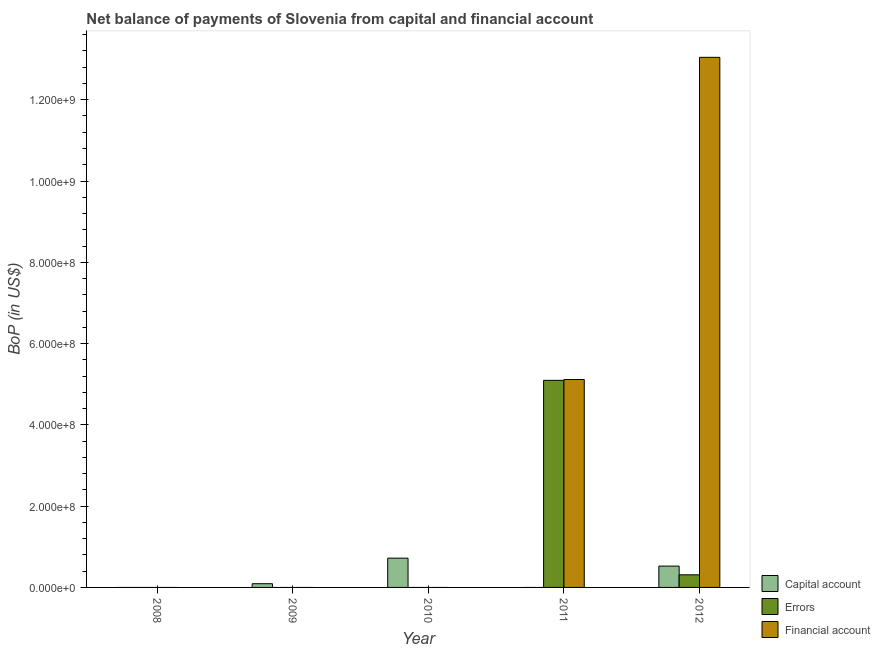How many different coloured bars are there?
Provide a succinct answer. 3. Are the number of bars per tick equal to the number of legend labels?
Your answer should be compact. No. Are the number of bars on each tick of the X-axis equal?
Your answer should be very brief. No. In how many cases, is the number of bars for a given year not equal to the number of legend labels?
Make the answer very short. 4. Across all years, what is the maximum amount of errors?
Give a very brief answer. 5.10e+08. In which year was the amount of errors maximum?
Offer a very short reply. 2011. What is the total amount of net capital account in the graph?
Make the answer very short. 1.34e+08. What is the difference between the amount of financial account in 2011 and that in 2012?
Ensure brevity in your answer.  -7.93e+08. What is the difference between the amount of errors in 2008 and the amount of financial account in 2009?
Offer a very short reply. 0. What is the average amount of errors per year?
Provide a succinct answer. 1.08e+08. In the year 2011, what is the difference between the amount of financial account and amount of net capital account?
Offer a terse response. 0. In how many years, is the amount of financial account greater than 1040000000 US$?
Provide a succinct answer. 1. What is the ratio of the amount of errors in 2011 to that in 2012?
Offer a terse response. 16.42. What is the difference between the highest and the lowest amount of errors?
Your answer should be compact. 5.10e+08. In how many years, is the amount of financial account greater than the average amount of financial account taken over all years?
Keep it short and to the point. 2. How many bars are there?
Offer a very short reply. 7. Are the values on the major ticks of Y-axis written in scientific E-notation?
Your response must be concise. Yes. Does the graph contain any zero values?
Provide a succinct answer. Yes. How many legend labels are there?
Your answer should be compact. 3. What is the title of the graph?
Your answer should be very brief. Net balance of payments of Slovenia from capital and financial account. What is the label or title of the Y-axis?
Offer a terse response. BoP (in US$). What is the BoP (in US$) of Capital account in 2008?
Your answer should be compact. 0. What is the BoP (in US$) in Errors in 2008?
Make the answer very short. 0. What is the BoP (in US$) in Capital account in 2009?
Provide a succinct answer. 9.16e+06. What is the BoP (in US$) in Errors in 2009?
Give a very brief answer. 0. What is the BoP (in US$) in Financial account in 2009?
Your response must be concise. 0. What is the BoP (in US$) of Capital account in 2010?
Provide a short and direct response. 7.20e+07. What is the BoP (in US$) in Financial account in 2010?
Give a very brief answer. 0. What is the BoP (in US$) of Capital account in 2011?
Your answer should be compact. 0. What is the BoP (in US$) of Errors in 2011?
Your answer should be compact. 5.10e+08. What is the BoP (in US$) of Financial account in 2011?
Provide a succinct answer. 5.12e+08. What is the BoP (in US$) of Capital account in 2012?
Keep it short and to the point. 5.25e+07. What is the BoP (in US$) in Errors in 2012?
Your response must be concise. 3.10e+07. What is the BoP (in US$) in Financial account in 2012?
Your answer should be very brief. 1.30e+09. Across all years, what is the maximum BoP (in US$) of Capital account?
Give a very brief answer. 7.20e+07. Across all years, what is the maximum BoP (in US$) of Errors?
Offer a terse response. 5.10e+08. Across all years, what is the maximum BoP (in US$) of Financial account?
Provide a succinct answer. 1.30e+09. Across all years, what is the minimum BoP (in US$) in Capital account?
Your response must be concise. 0. Across all years, what is the minimum BoP (in US$) of Errors?
Offer a very short reply. 0. Across all years, what is the minimum BoP (in US$) of Financial account?
Your response must be concise. 0. What is the total BoP (in US$) in Capital account in the graph?
Your answer should be compact. 1.34e+08. What is the total BoP (in US$) in Errors in the graph?
Provide a short and direct response. 5.41e+08. What is the total BoP (in US$) in Financial account in the graph?
Give a very brief answer. 1.82e+09. What is the difference between the BoP (in US$) in Capital account in 2009 and that in 2010?
Provide a succinct answer. -6.29e+07. What is the difference between the BoP (in US$) of Capital account in 2009 and that in 2012?
Keep it short and to the point. -4.33e+07. What is the difference between the BoP (in US$) in Capital account in 2010 and that in 2012?
Ensure brevity in your answer.  1.96e+07. What is the difference between the BoP (in US$) of Errors in 2011 and that in 2012?
Provide a succinct answer. 4.79e+08. What is the difference between the BoP (in US$) of Financial account in 2011 and that in 2012?
Offer a terse response. -7.93e+08. What is the difference between the BoP (in US$) of Capital account in 2009 and the BoP (in US$) of Errors in 2011?
Your answer should be compact. -5.00e+08. What is the difference between the BoP (in US$) in Capital account in 2009 and the BoP (in US$) in Financial account in 2011?
Ensure brevity in your answer.  -5.02e+08. What is the difference between the BoP (in US$) of Capital account in 2009 and the BoP (in US$) of Errors in 2012?
Provide a short and direct response. -2.19e+07. What is the difference between the BoP (in US$) of Capital account in 2009 and the BoP (in US$) of Financial account in 2012?
Provide a succinct answer. -1.30e+09. What is the difference between the BoP (in US$) in Capital account in 2010 and the BoP (in US$) in Errors in 2011?
Your answer should be compact. -4.38e+08. What is the difference between the BoP (in US$) in Capital account in 2010 and the BoP (in US$) in Financial account in 2011?
Provide a short and direct response. -4.40e+08. What is the difference between the BoP (in US$) of Capital account in 2010 and the BoP (in US$) of Errors in 2012?
Your answer should be compact. 4.10e+07. What is the difference between the BoP (in US$) in Capital account in 2010 and the BoP (in US$) in Financial account in 2012?
Your response must be concise. -1.23e+09. What is the difference between the BoP (in US$) in Errors in 2011 and the BoP (in US$) in Financial account in 2012?
Ensure brevity in your answer.  -7.95e+08. What is the average BoP (in US$) in Capital account per year?
Give a very brief answer. 2.67e+07. What is the average BoP (in US$) of Errors per year?
Offer a very short reply. 1.08e+08. What is the average BoP (in US$) of Financial account per year?
Your answer should be compact. 3.63e+08. In the year 2011, what is the difference between the BoP (in US$) of Errors and BoP (in US$) of Financial account?
Offer a terse response. -2.00e+06. In the year 2012, what is the difference between the BoP (in US$) of Capital account and BoP (in US$) of Errors?
Your answer should be compact. 2.14e+07. In the year 2012, what is the difference between the BoP (in US$) in Capital account and BoP (in US$) in Financial account?
Provide a short and direct response. -1.25e+09. In the year 2012, what is the difference between the BoP (in US$) of Errors and BoP (in US$) of Financial account?
Ensure brevity in your answer.  -1.27e+09. What is the ratio of the BoP (in US$) of Capital account in 2009 to that in 2010?
Provide a short and direct response. 0.13. What is the ratio of the BoP (in US$) of Capital account in 2009 to that in 2012?
Your answer should be compact. 0.17. What is the ratio of the BoP (in US$) in Capital account in 2010 to that in 2012?
Offer a terse response. 1.37. What is the ratio of the BoP (in US$) in Errors in 2011 to that in 2012?
Your response must be concise. 16.42. What is the ratio of the BoP (in US$) in Financial account in 2011 to that in 2012?
Make the answer very short. 0.39. What is the difference between the highest and the second highest BoP (in US$) of Capital account?
Ensure brevity in your answer.  1.96e+07. What is the difference between the highest and the lowest BoP (in US$) in Capital account?
Your answer should be compact. 7.20e+07. What is the difference between the highest and the lowest BoP (in US$) of Errors?
Your answer should be compact. 5.10e+08. What is the difference between the highest and the lowest BoP (in US$) in Financial account?
Provide a succinct answer. 1.30e+09. 